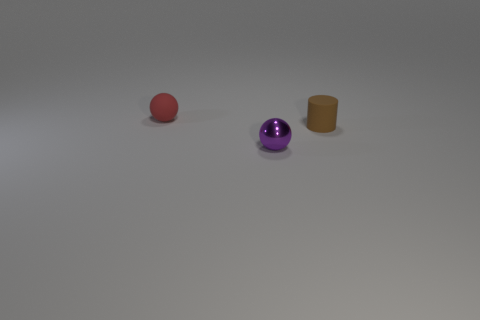There is a shiny sphere that is the same size as the rubber cylinder; what color is it?
Give a very brief answer. Purple. There is a rubber thing that is the same shape as the metal object; what size is it?
Give a very brief answer. Small. There is a small object on the left side of the small purple sphere; what shape is it?
Your answer should be compact. Sphere. Do the red rubber thing and the purple metallic object in front of the brown object have the same shape?
Offer a terse response. Yes. Are there the same number of red things that are on the right side of the tiny matte cylinder and rubber things in front of the tiny shiny thing?
Offer a very short reply. Yes. There is a small sphere behind the metal ball; is its color the same as the tiny ball to the right of the red rubber ball?
Offer a terse response. No. Are there more matte cylinders in front of the tiny cylinder than red balls?
Your response must be concise. No. What is the material of the purple thing?
Offer a terse response. Metal. There is a brown object that is the same material as the tiny red ball; what is its shape?
Make the answer very short. Cylinder. What size is the sphere in front of the tiny rubber thing that is on the right side of the red matte object?
Provide a succinct answer. Small. 